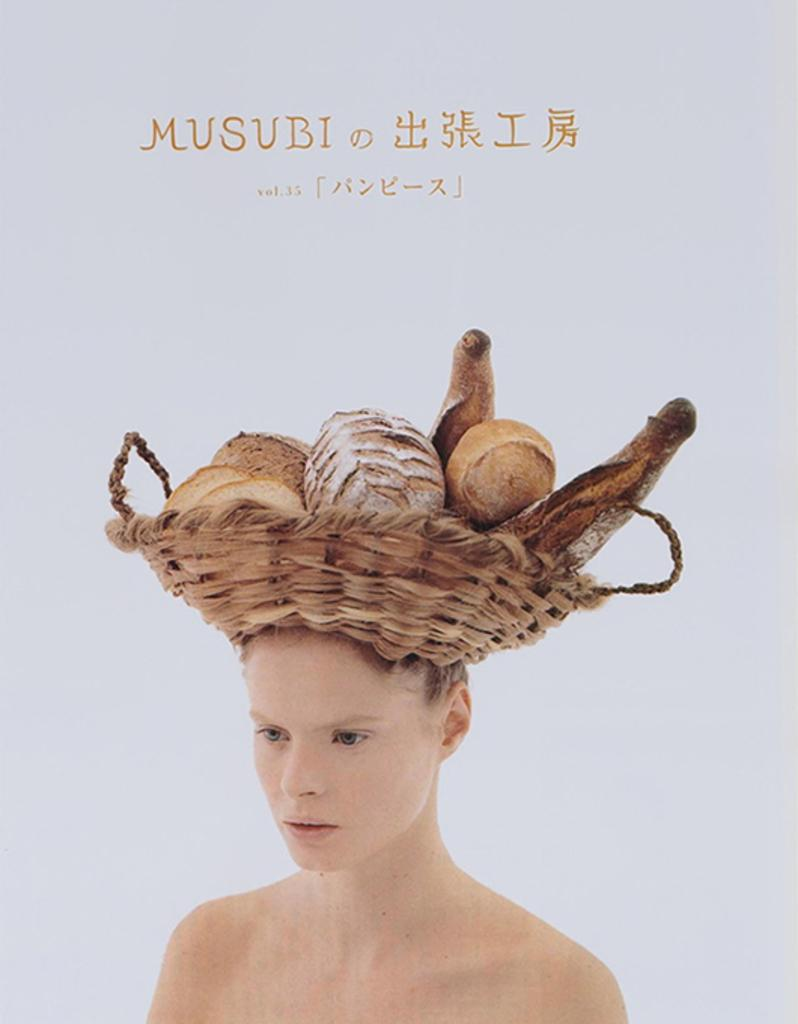What type of visual is depicted in the image? The image is a poster. Who or what is featured in the poster? There is a person in the poster. What is the person doing in the poster? The person is carrying a basket on their head. What can be found inside the basket? There are objects in the basket. Is there any text present in the poster? Yes, there is text in the poster. Where is the scarecrow located in the poster? There is no scarecrow present in the poster. How many family members are visible in the poster? There is no family depicted in the poster; it features a single person carrying a basket. 